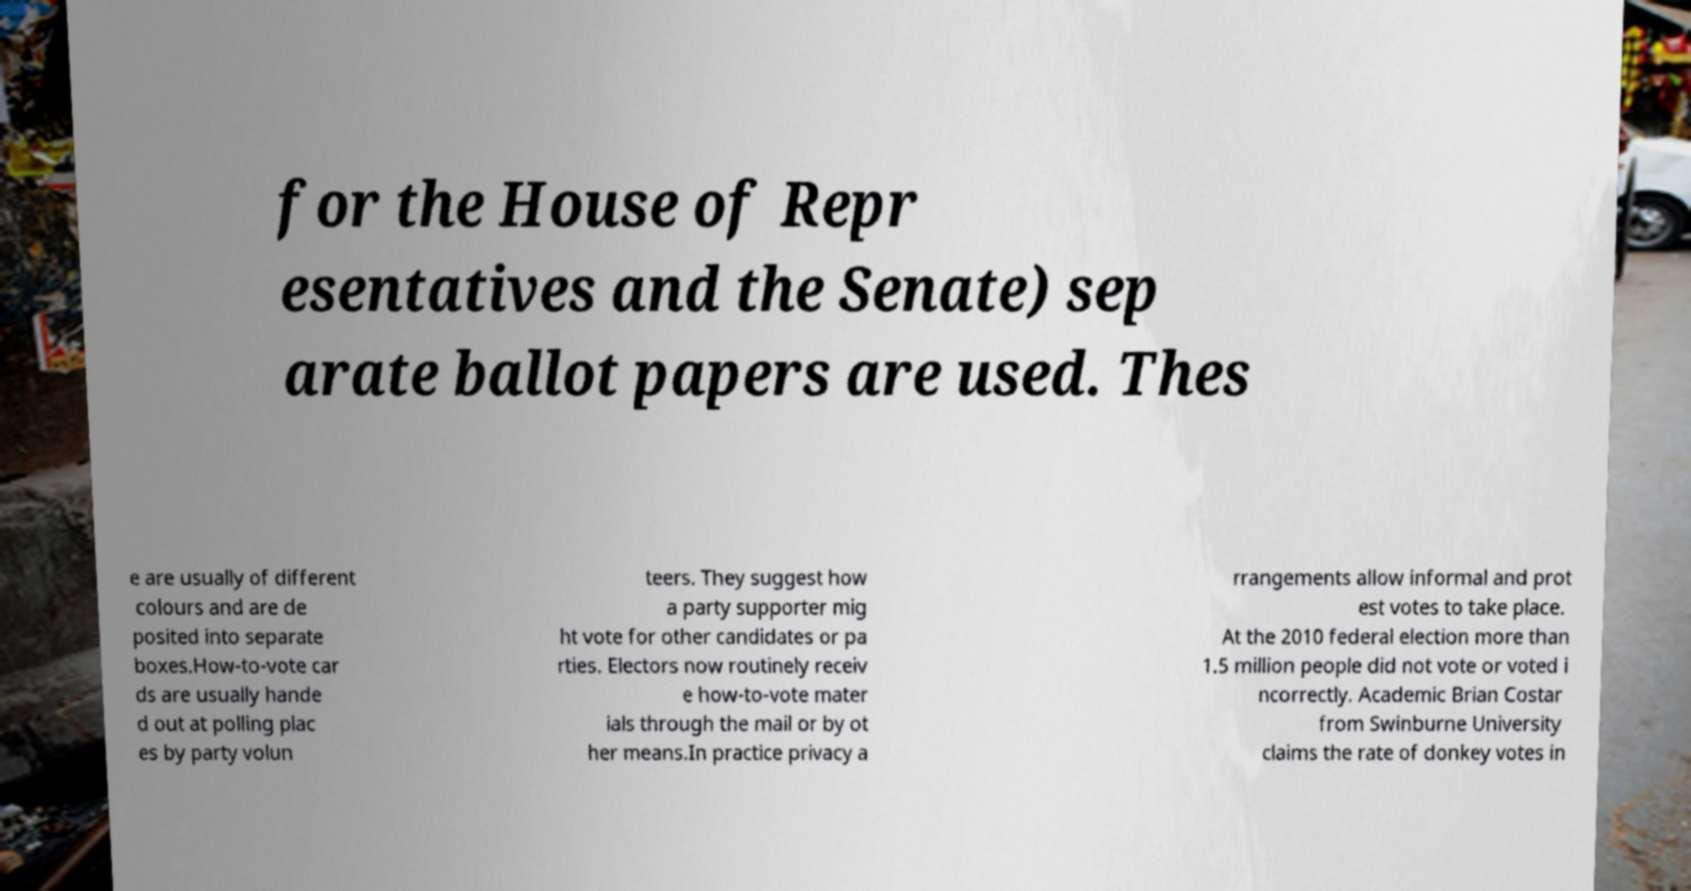For documentation purposes, I need the text within this image transcribed. Could you provide that? for the House of Repr esentatives and the Senate) sep arate ballot papers are used. Thes e are usually of different colours and are de posited into separate boxes.How-to-vote car ds are usually hande d out at polling plac es by party volun teers. They suggest how a party supporter mig ht vote for other candidates or pa rties. Electors now routinely receiv e how-to-vote mater ials through the mail or by ot her means.In practice privacy a rrangements allow informal and prot est votes to take place. At the 2010 federal election more than 1.5 million people did not vote or voted i ncorrectly. Academic Brian Costar from Swinburne University claims the rate of donkey votes in 